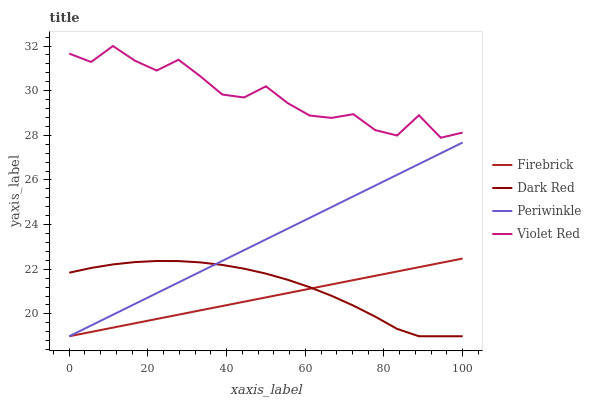Does Firebrick have the minimum area under the curve?
Answer yes or no. Yes. Does Violet Red have the maximum area under the curve?
Answer yes or no. Yes. Does Periwinkle have the minimum area under the curve?
Answer yes or no. No. Does Periwinkle have the maximum area under the curve?
Answer yes or no. No. Is Periwinkle the smoothest?
Answer yes or no. Yes. Is Violet Red the roughest?
Answer yes or no. Yes. Is Firebrick the smoothest?
Answer yes or no. No. Is Firebrick the roughest?
Answer yes or no. No. Does Dark Red have the lowest value?
Answer yes or no. Yes. Does Violet Red have the lowest value?
Answer yes or no. No. Does Violet Red have the highest value?
Answer yes or no. Yes. Does Firebrick have the highest value?
Answer yes or no. No. Is Dark Red less than Violet Red?
Answer yes or no. Yes. Is Violet Red greater than Periwinkle?
Answer yes or no. Yes. Does Periwinkle intersect Dark Red?
Answer yes or no. Yes. Is Periwinkle less than Dark Red?
Answer yes or no. No. Is Periwinkle greater than Dark Red?
Answer yes or no. No. Does Dark Red intersect Violet Red?
Answer yes or no. No. 